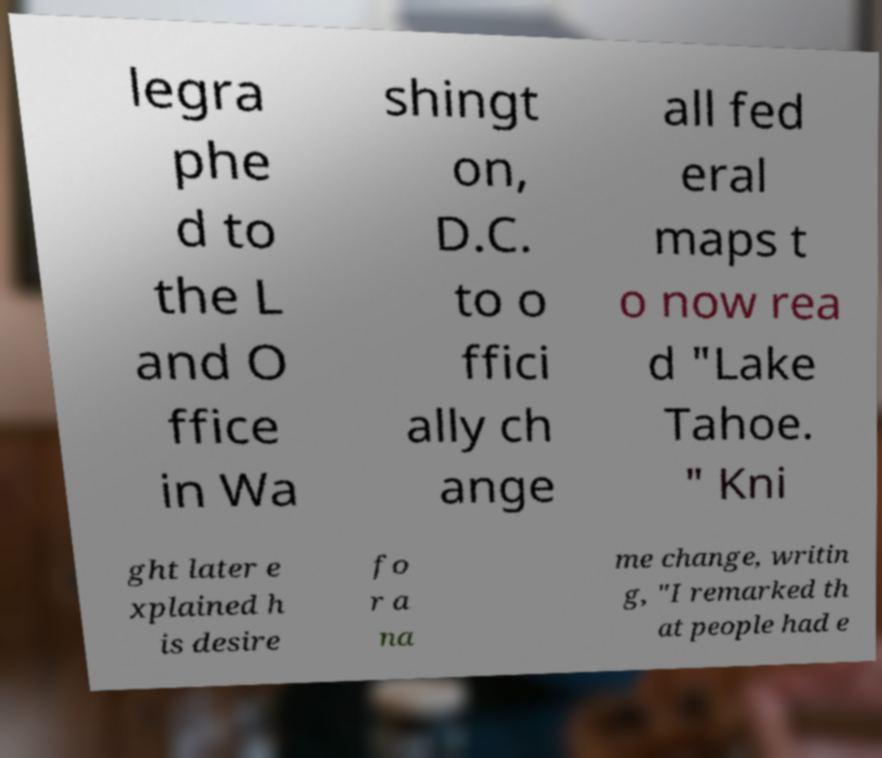Could you assist in decoding the text presented in this image and type it out clearly? legra phe d to the L and O ffice in Wa shingt on, D.C. to o ffici ally ch ange all fed eral maps t o now rea d "Lake Tahoe. " Kni ght later e xplained h is desire fo r a na me change, writin g, "I remarked th at people had e 